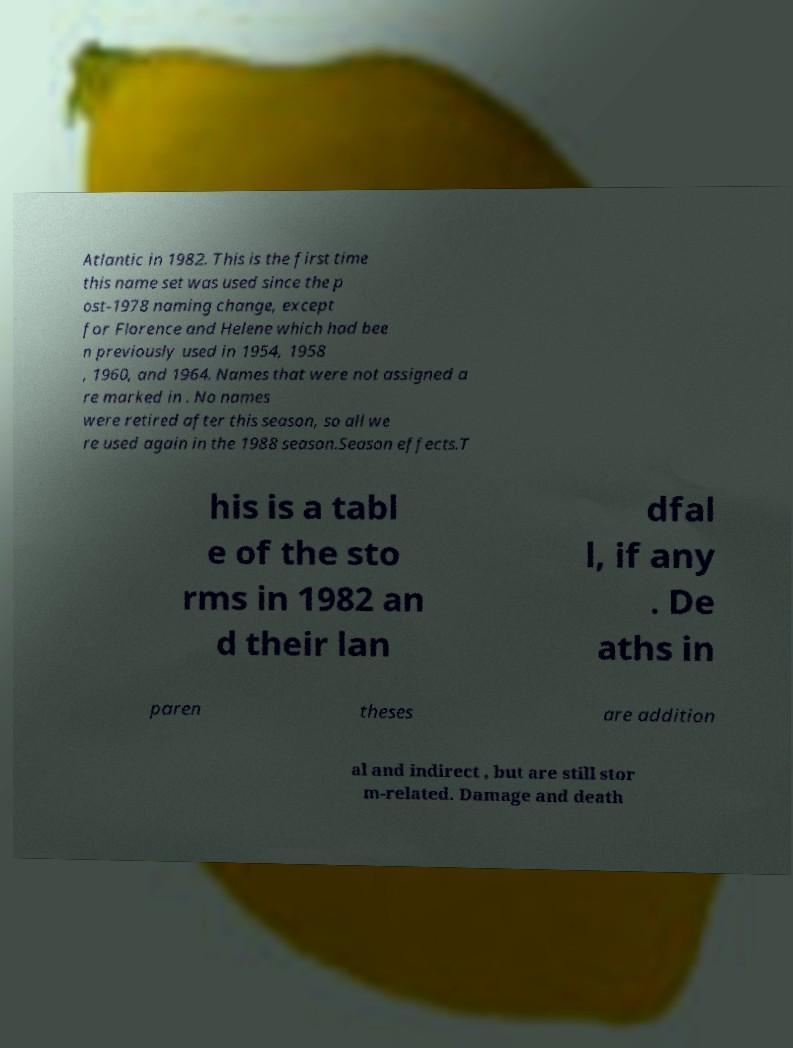There's text embedded in this image that I need extracted. Can you transcribe it verbatim? Atlantic in 1982. This is the first time this name set was used since the p ost-1978 naming change, except for Florence and Helene which had bee n previously used in 1954, 1958 , 1960, and 1964. Names that were not assigned a re marked in . No names were retired after this season, so all we re used again in the 1988 season.Season effects.T his is a tabl e of the sto rms in 1982 an d their lan dfal l, if any . De aths in paren theses are addition al and indirect , but are still stor m-related. Damage and death 